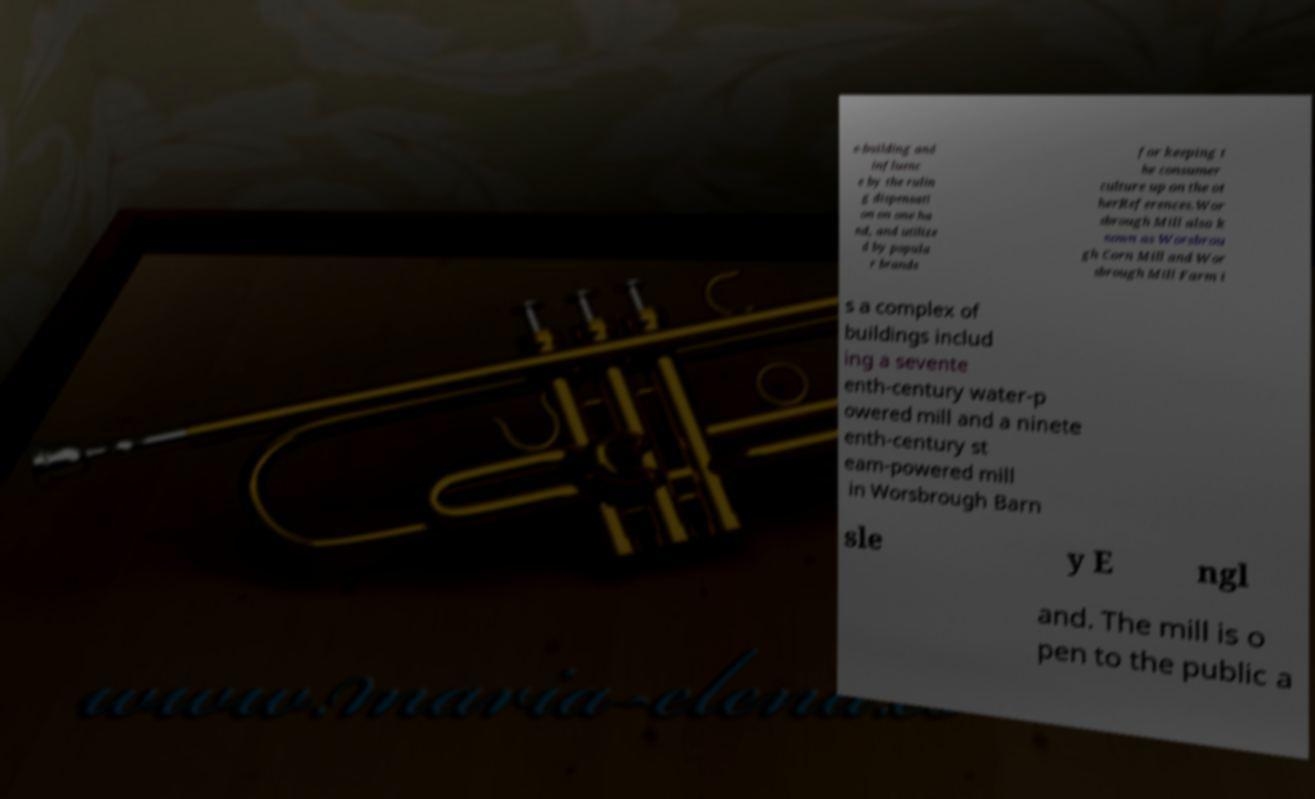What messages or text are displayed in this image? I need them in a readable, typed format. e-building and influenc e by the rulin g dispensati on on one ha nd, and utilize d by popula r brands for keeping t he consumer culture up on the ot herReferences.Wor sbrough Mill also k nown as Worsbrou gh Corn Mill and Wor sbrough Mill Farm i s a complex of buildings includ ing a sevente enth-century water-p owered mill and a ninete enth-century st eam-powered mill in Worsbrough Barn sle y E ngl and. The mill is o pen to the public a 